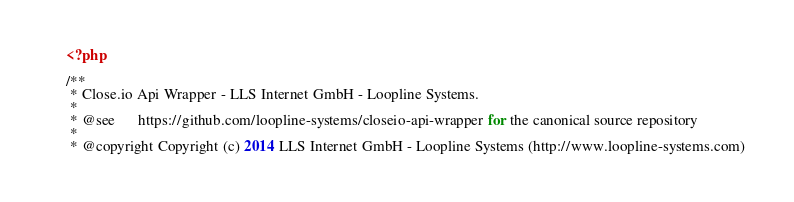Convert code to text. <code><loc_0><loc_0><loc_500><loc_500><_PHP_><?php

/**
 * Close.io Api Wrapper - LLS Internet GmbH - Loopline Systems.
 *
 * @see      https://github.com/loopline-systems/closeio-api-wrapper for the canonical source repository
 *
 * @copyright Copyright (c) 2014 LLS Internet GmbH - Loopline Systems (http://www.loopline-systems.com)</code> 